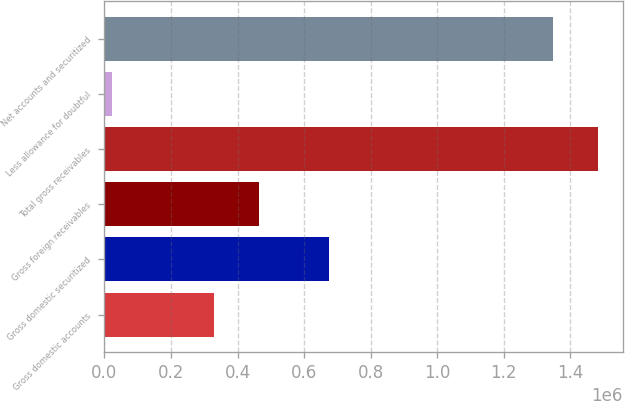Convert chart. <chart><loc_0><loc_0><loc_500><loc_500><bar_chart><fcel>Gross domestic accounts<fcel>Gross domestic securitized<fcel>Gross foreign receivables<fcel>Total gross receivables<fcel>Less allowance for doubtful<fcel>Net accounts and securitized<nl><fcel>330466<fcel>675000<fcel>465346<fcel>1.48368e+06<fcel>23842<fcel>1.3488e+06<nl></chart> 